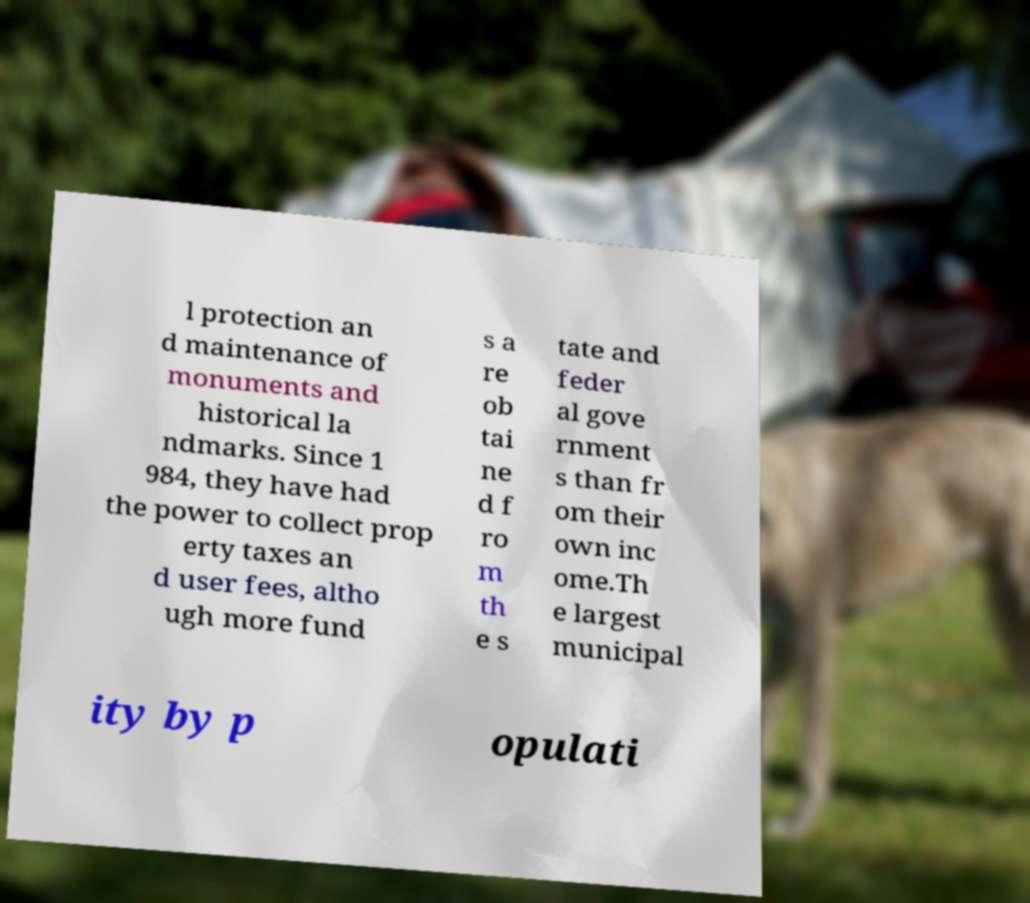Could you assist in decoding the text presented in this image and type it out clearly? l protection an d maintenance of monuments and historical la ndmarks. Since 1 984, they have had the power to collect prop erty taxes an d user fees, altho ugh more fund s a re ob tai ne d f ro m th e s tate and feder al gove rnment s than fr om their own inc ome.Th e largest municipal ity by p opulati 